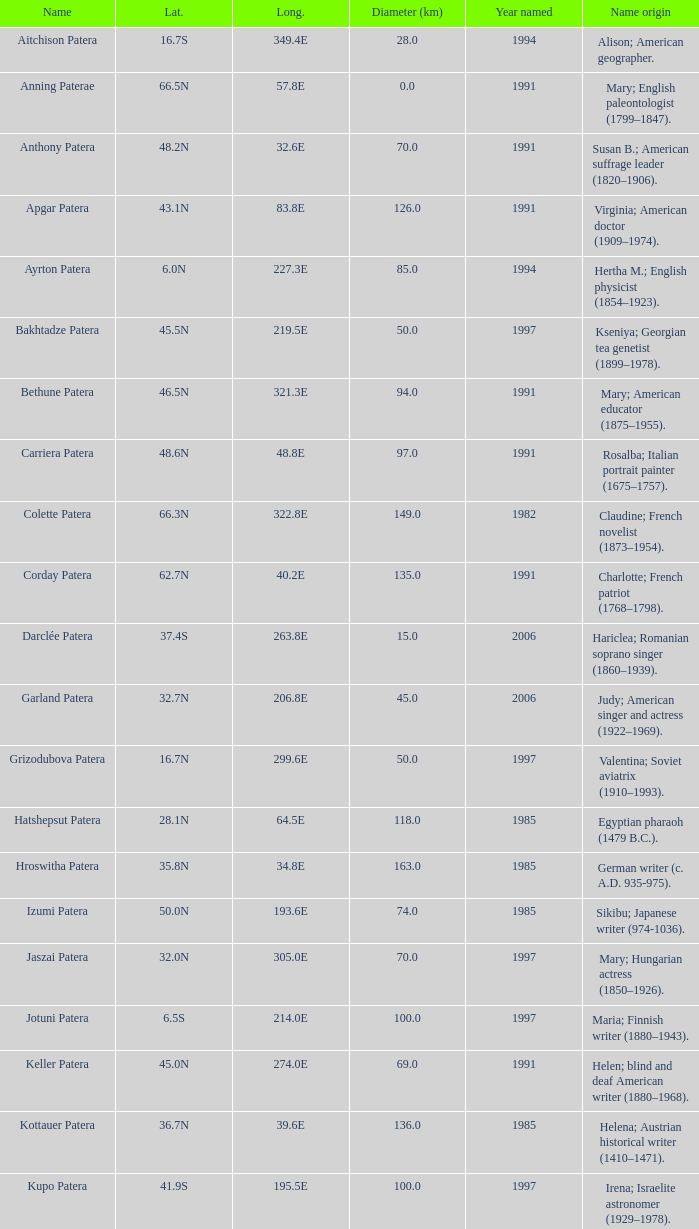What is the diameter in km of the feature named Colette Patera?  149.0. 